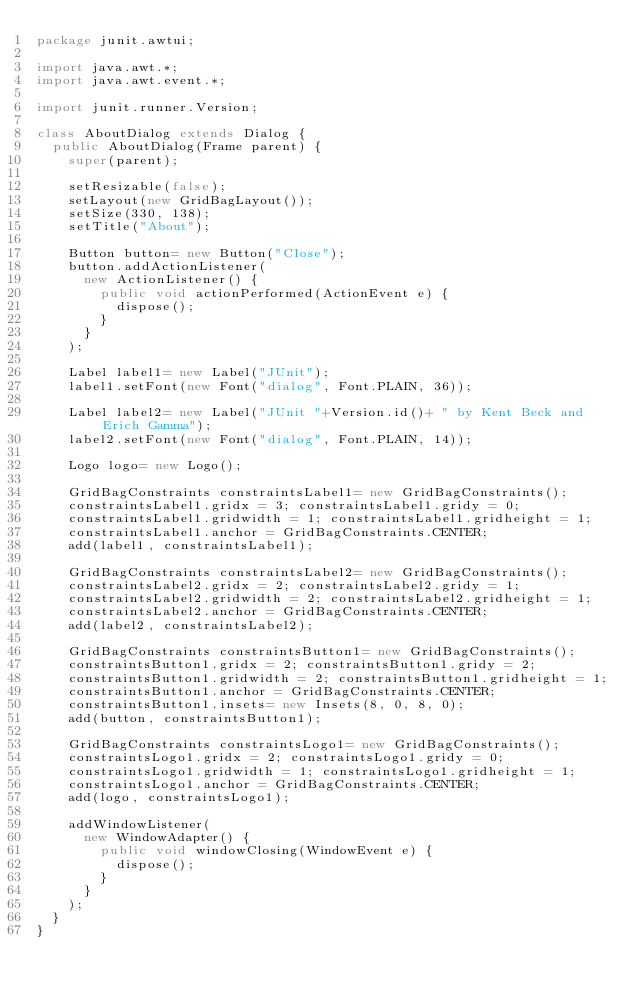Convert code to text. <code><loc_0><loc_0><loc_500><loc_500><_Java_>package junit.awtui;

import java.awt.*;
import java.awt.event.*;

import junit.runner.Version;

class AboutDialog extends Dialog {
	public AboutDialog(Frame parent) {
		super(parent);
		
		setResizable(false);
		setLayout(new GridBagLayout());
		setSize(330, 138);
		setTitle("About");
		
		Button button= new Button("Close");
		button.addActionListener(
			new ActionListener() {
				public void actionPerformed(ActionEvent e) {
					dispose();
				}
			}
		);
		
		Label label1= new Label("JUnit");
		label1.setFont(new Font("dialog", Font.PLAIN, 36));
		
		Label label2= new Label("JUnit "+Version.id()+ " by Kent Beck and Erich Gamma");
		label2.setFont(new Font("dialog", Font.PLAIN, 14));
		
		Logo logo= new Logo();

		GridBagConstraints constraintsLabel1= new GridBagConstraints();
		constraintsLabel1.gridx = 3; constraintsLabel1.gridy = 0;
		constraintsLabel1.gridwidth = 1; constraintsLabel1.gridheight = 1;
		constraintsLabel1.anchor = GridBagConstraints.CENTER;
		add(label1, constraintsLabel1);

		GridBagConstraints constraintsLabel2= new GridBagConstraints();
		constraintsLabel2.gridx = 2; constraintsLabel2.gridy = 1;
		constraintsLabel2.gridwidth = 2; constraintsLabel2.gridheight = 1;
		constraintsLabel2.anchor = GridBagConstraints.CENTER;
		add(label2, constraintsLabel2);

		GridBagConstraints constraintsButton1= new GridBagConstraints();
		constraintsButton1.gridx = 2; constraintsButton1.gridy = 2;
		constraintsButton1.gridwidth = 2; constraintsButton1.gridheight = 1;
		constraintsButton1.anchor = GridBagConstraints.CENTER;
		constraintsButton1.insets= new Insets(8, 0, 8, 0);
		add(button, constraintsButton1);

		GridBagConstraints constraintsLogo1= new GridBagConstraints();
		constraintsLogo1.gridx = 2; constraintsLogo1.gridy = 0;
		constraintsLogo1.gridwidth = 1; constraintsLogo1.gridheight = 1;
		constraintsLogo1.anchor = GridBagConstraints.CENTER;
		add(logo, constraintsLogo1);

		addWindowListener(
			new WindowAdapter() {
				public void windowClosing(WindowEvent e) {
					dispose();
				}
			}
		);
	}
}</code> 